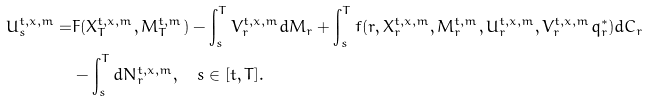Convert formula to latex. <formula><loc_0><loc_0><loc_500><loc_500>U _ { s } ^ { t , x , m } = & F ( X _ { T } ^ { t , x , m } , M _ { T } ^ { t , m } ) - \int _ { s } ^ { T } V _ { r } ^ { t , x , m } d M _ { r } + \int _ { s } ^ { T } f ( r , X _ { r } ^ { t , x , m } , M _ { r } ^ { t , m } , U _ { r } ^ { t , x , m } , V _ { r } ^ { t , x , m } q ^ { * } _ { r } ) d C _ { r } \\ & - \int _ { s } ^ { T } d N ^ { t , x , m } _ { r } , \quad s \in [ t , T ] .</formula> 